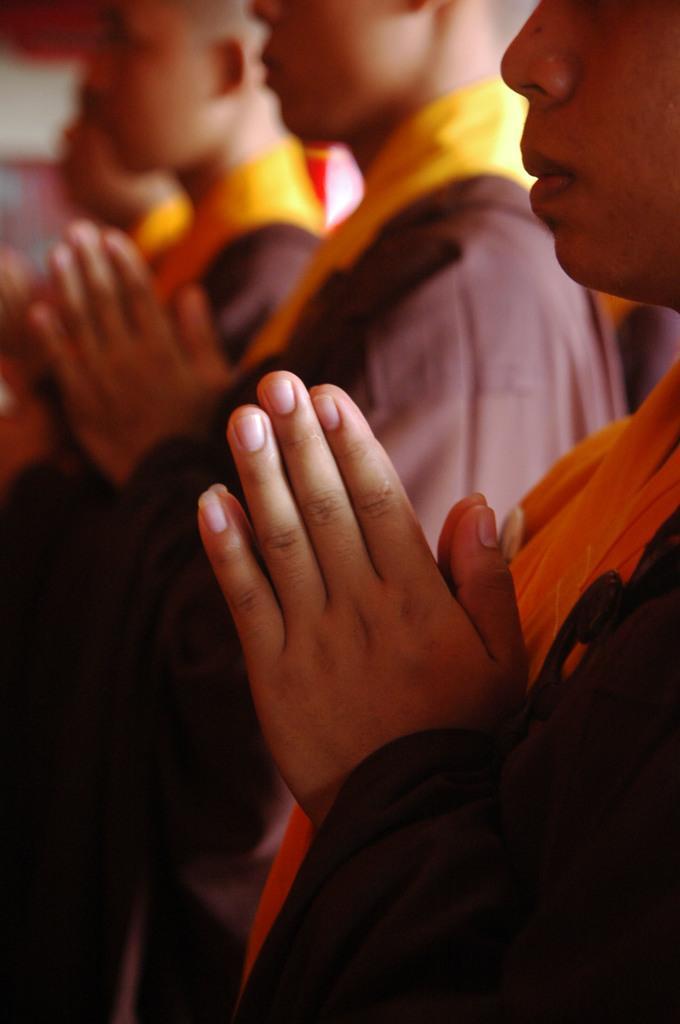In one or two sentences, can you explain what this image depicts? In this image we can see few people. In the background it is blur. 